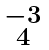Convert formula to latex. <formula><loc_0><loc_0><loc_500><loc_500>\begin{smallmatrix} - 3 \\ 4 \end{smallmatrix}</formula> 